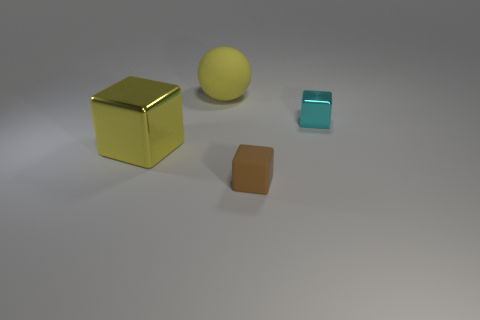What material is the small brown thing that is the same shape as the large yellow metal thing?
Your answer should be compact. Rubber. Do the large shiny block and the ball have the same color?
Your answer should be compact. Yes. What shape is the big yellow thing in front of the big object behind the cyan shiny block?
Give a very brief answer. Cube. There is a large object that is made of the same material as the small brown thing; what is its shape?
Provide a succinct answer. Sphere. What number of other things are there of the same shape as the cyan thing?
Provide a succinct answer. 2. Is the size of the shiny thing to the left of the brown thing the same as the small rubber object?
Keep it short and to the point. No. Is the number of matte cubes that are behind the brown matte block greater than the number of small rubber things?
Ensure brevity in your answer.  No. There is a cube that is on the right side of the tiny rubber object; what number of big yellow balls are behind it?
Your answer should be compact. 1. Is the number of big metallic things right of the yellow matte ball less than the number of spheres?
Offer a terse response. Yes. There is a tiny thing to the left of the shiny object that is on the right side of the small brown cube; are there any big yellow objects to the right of it?
Provide a short and direct response. No. 